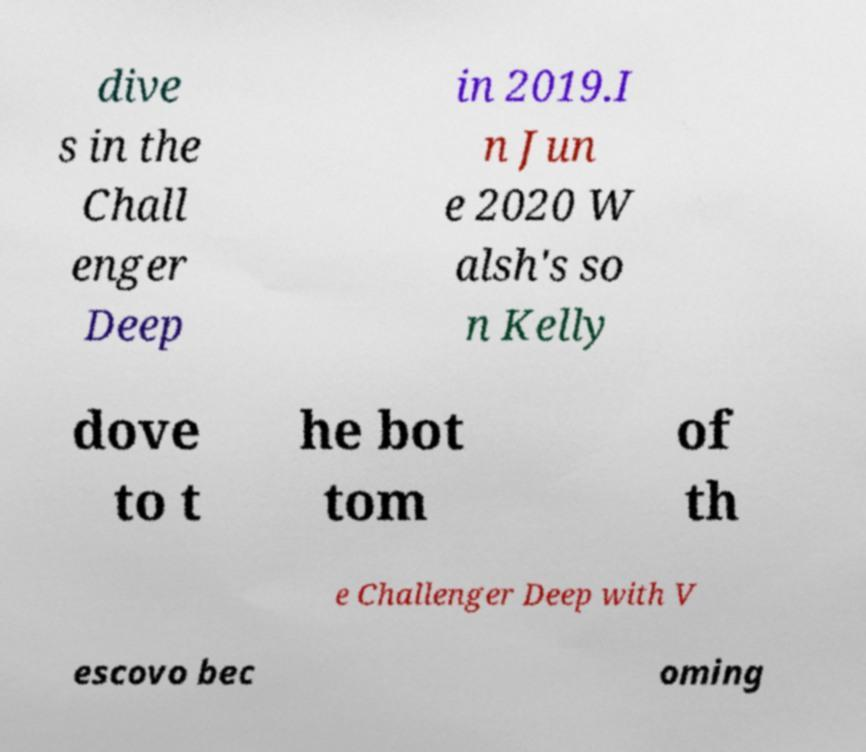Could you extract and type out the text from this image? dive s in the Chall enger Deep in 2019.I n Jun e 2020 W alsh's so n Kelly dove to t he bot tom of th e Challenger Deep with V escovo bec oming 